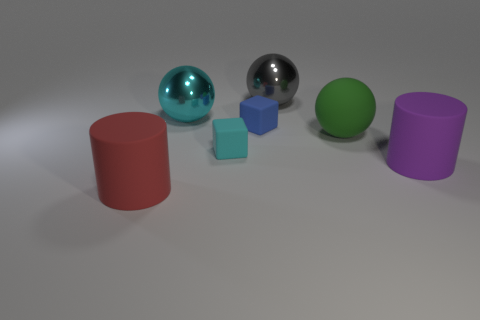There is a blue block that is the same size as the cyan rubber object; what material is it?
Ensure brevity in your answer.  Rubber. There is a large object that is in front of the cyan metal sphere and behind the big purple matte thing; what is it made of?
Give a very brief answer. Rubber. Is there a big gray object that is left of the green thing on the right side of the large red matte cylinder?
Your answer should be very brief. Yes. There is a ball that is behind the green rubber thing and to the right of the big cyan thing; what size is it?
Your answer should be compact. Large. How many gray objects are either blocks or big rubber balls?
Give a very brief answer. 0. There is a red matte thing that is the same size as the gray ball; what is its shape?
Keep it short and to the point. Cylinder. What number of other things are there of the same color as the large matte ball?
Give a very brief answer. 0. There is a matte cube that is on the left side of the rubber block that is behind the green rubber thing; how big is it?
Provide a short and direct response. Small. Is the material of the large cylinder that is on the right side of the big red thing the same as the large cyan sphere?
Your answer should be compact. No. There is a big object to the left of the large cyan thing; what shape is it?
Offer a very short reply. Cylinder. 